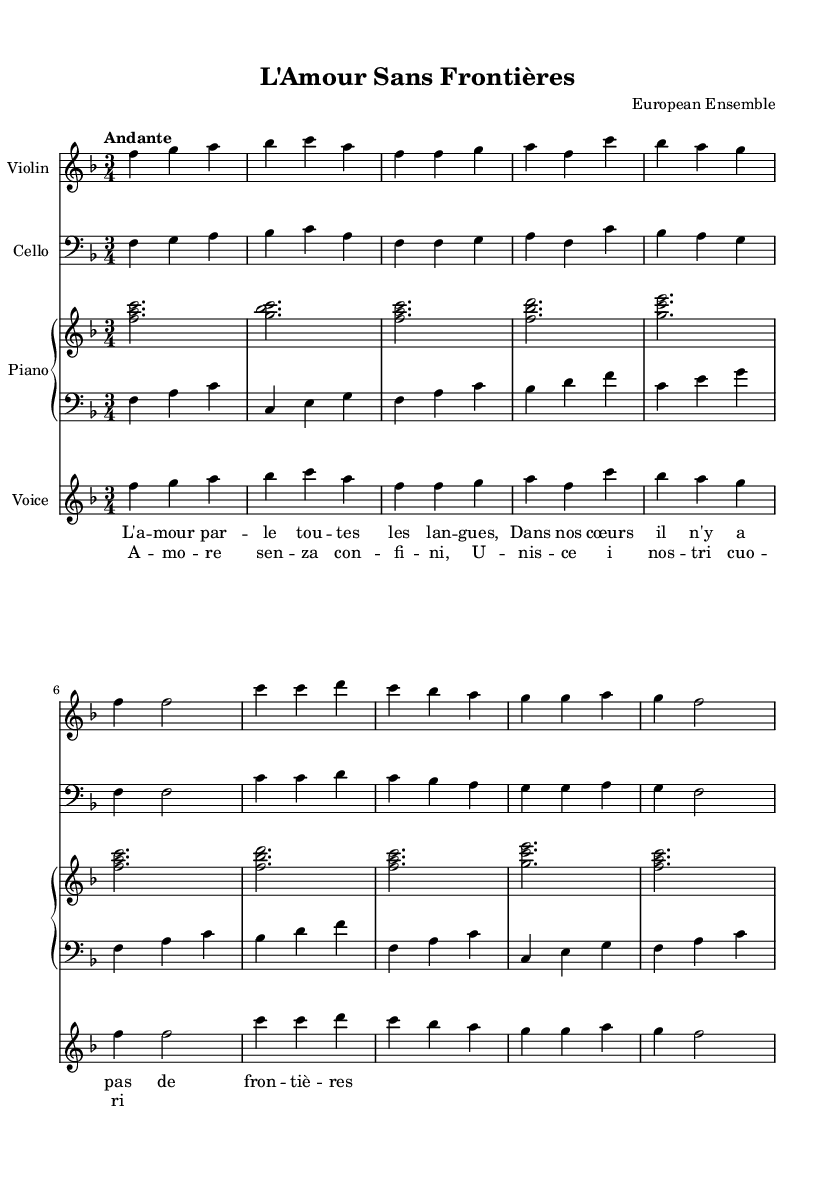What is the key signature of this music? The key signature is F major, which has one flat (B flat). This can be identified by looking at the key signature indicated at the beginning of the score, just after the clef symbol.
Answer: F major What is the time signature of this music? The time signature is 3/4, which indicates that there are three beats in a measure and the quarter note gets one beat. This is found at the beginning of the score following the key signature.
Answer: 3/4 What is the tempo marking for this piece? The tempo marking is "Andante", which indicates a moderate walking pace. This is typically noted at the beginning of the score, after the time signature.
Answer: Andante How many lines are in the piano staff? The piano staff consists of five lines for each staff (right and left), totaling ten lines. This can be counted by observing the staves labeled as "right" and "left" within the score.
Answer: Ten Which instrument plays the melody prominently? The violin plays the melody prominently throughout the piece, as seen in the first staff named "Violin." The notes played here frequently outline the overarching melodic structure of the music.
Answer: Violin What is the main theme of the lyrics? The main theme of the lyrics revolves around love transcending language barriers ("L'amour par le toutes les langues"), indicating the universal nature of love across cultures. This can be derived from reading the lyrics provided under the respective music staff.
Answer: Love transcending languages How does the structure of the song progress? The structure follows a pattern of Intro, Verse, and Chorus. The Intro introduces the musical theme, the Verse carries the narrative, and the Chorus reinforces the main message of the song. This is observed by analyzing the different sections labeled in the music, which denote this flow.
Answer: Intro, Verse, Chorus 